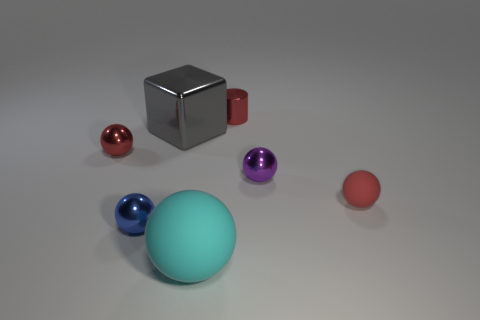Subtract all large cyan matte balls. How many balls are left? 4 Subtract all blue balls. How many balls are left? 4 Subtract all yellow spheres. Subtract all yellow cylinders. How many spheres are left? 5 Add 1 tiny green rubber blocks. How many objects exist? 8 Subtract all cubes. How many objects are left? 6 Add 5 small cyan cubes. How many small cyan cubes exist? 5 Subtract 0 blue blocks. How many objects are left? 7 Subtract all blue spheres. Subtract all small cylinders. How many objects are left? 5 Add 7 large metallic objects. How many large metallic objects are left? 8 